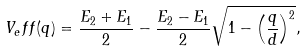<formula> <loc_0><loc_0><loc_500><loc_500>V _ { e } f f ( q ) = \frac { E _ { 2 } + E _ { 1 } } { 2 } - \frac { E _ { 2 } - E _ { 1 } } { 2 } \sqrt { 1 - \left ( \frac { q } { d } \right ) ^ { 2 } } ,</formula> 